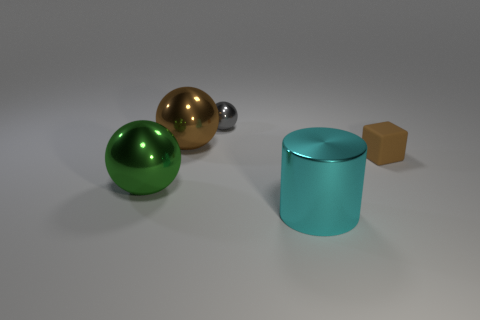Is there anything else that is the same material as the small cube?
Provide a short and direct response. No. Are there any brown metal spheres behind the big metal thing that is right of the gray shiny thing?
Keep it short and to the point. Yes. What number of tiny things are on the right side of the large cyan metal object and behind the large brown sphere?
Keep it short and to the point. 0. How many green spheres have the same material as the large brown object?
Provide a succinct answer. 1. There is a object that is on the right side of the big metal thing that is on the right side of the gray sphere; how big is it?
Keep it short and to the point. Small. Is there another thing that has the same shape as the small gray object?
Keep it short and to the point. Yes. Is the size of the gray sphere that is behind the tiny brown thing the same as the thing to the right of the large cyan object?
Give a very brief answer. Yes. Are there fewer big green things right of the cyan shiny object than large metal things that are behind the gray object?
Offer a very short reply. No. There is a big ball that is the same color as the cube; what is its material?
Your response must be concise. Metal. There is a large shiny sphere that is to the left of the brown sphere; what color is it?
Make the answer very short. Green. 